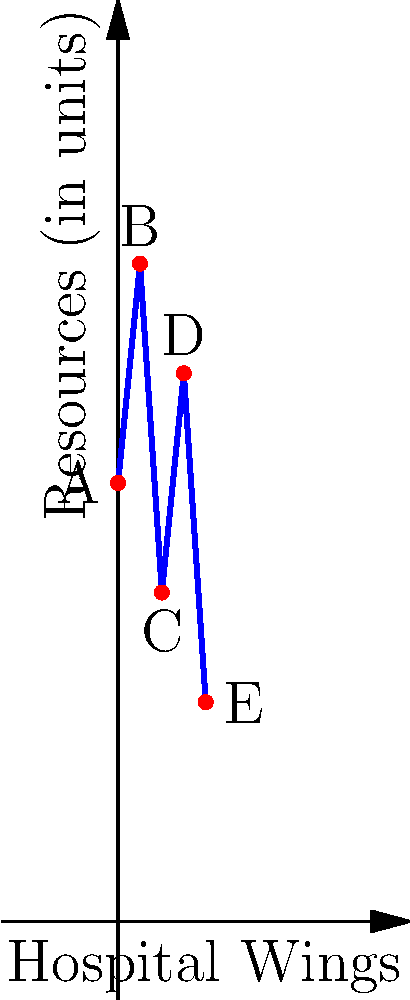The graph shows the current resource allocation across five hospital wings (A, B, C, D, and E). If we represent this allocation as a vector $\mathbf{v} = [20, 30, 15, 25, 10]$, and the hospital decides to increase resources in wings B and D by 5 units each while decreasing resources in wings A and C by 3 units each, what would be the resulting resource allocation vector? Let's approach this step-by-step:

1) The initial resource allocation vector is $\mathbf{v} = [20, 30, 15, 25, 10]$.

2) We need to make the following changes:
   - Increase B (2nd element) by 5 units
   - Increase D (4th element) by 5 units
   - Decrease A (1st element) by 3 units
   - Decrease C (3rd element) by 3 units
   - E (5th element) remains unchanged

3) Let's create a change vector $\mathbf{c}$ to represent these adjustments:
   $\mathbf{c} = [-3, 5, -3, 5, 0]$

4) The new resource allocation vector $\mathbf{v_{new}}$ will be the sum of $\mathbf{v}$ and $\mathbf{c}$:

   $\mathbf{v_{new}} = \mathbf{v} + \mathbf{c}$

5) Let's perform the vector addition:

   $\mathbf{v_{new}} = [20, 30, 15, 25, 10] + [-3, 5, -3, 5, 0]$

6) Adding the corresponding elements:

   $\mathbf{v_{new}} = [20-3, 30+5, 15-3, 25+5, 10+0]$

7) Simplifying:

   $\mathbf{v_{new}} = [17, 35, 12, 30, 10]$

Therefore, the resulting resource allocation vector is $[17, 35, 12, 30, 10]$.
Answer: $[17, 35, 12, 30, 10]$ 